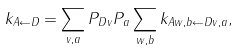<formula> <loc_0><loc_0><loc_500><loc_500>k _ { A \leftarrow D } = \sum _ { v , a } P _ { D v } P _ { a } \sum _ { w , b } k _ { A w , b \leftarrow D v , a } ,</formula> 